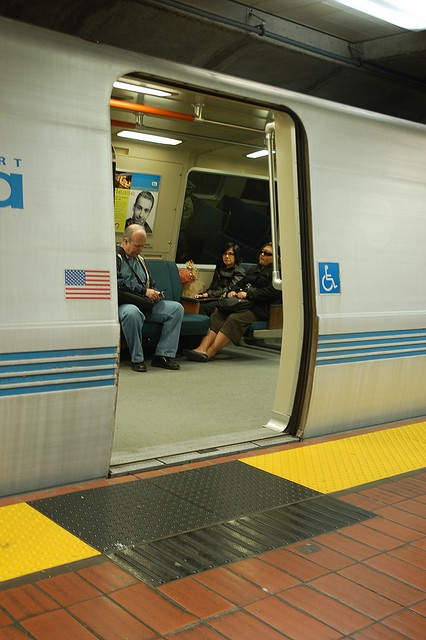Describe the objects in this image and their specific colors. I can see train in black, darkgray, tan, and lightgray tones, people in black, teal, and maroon tones, people in black, olive, maroon, and brown tones, and people in black, olive, and maroon tones in this image. 